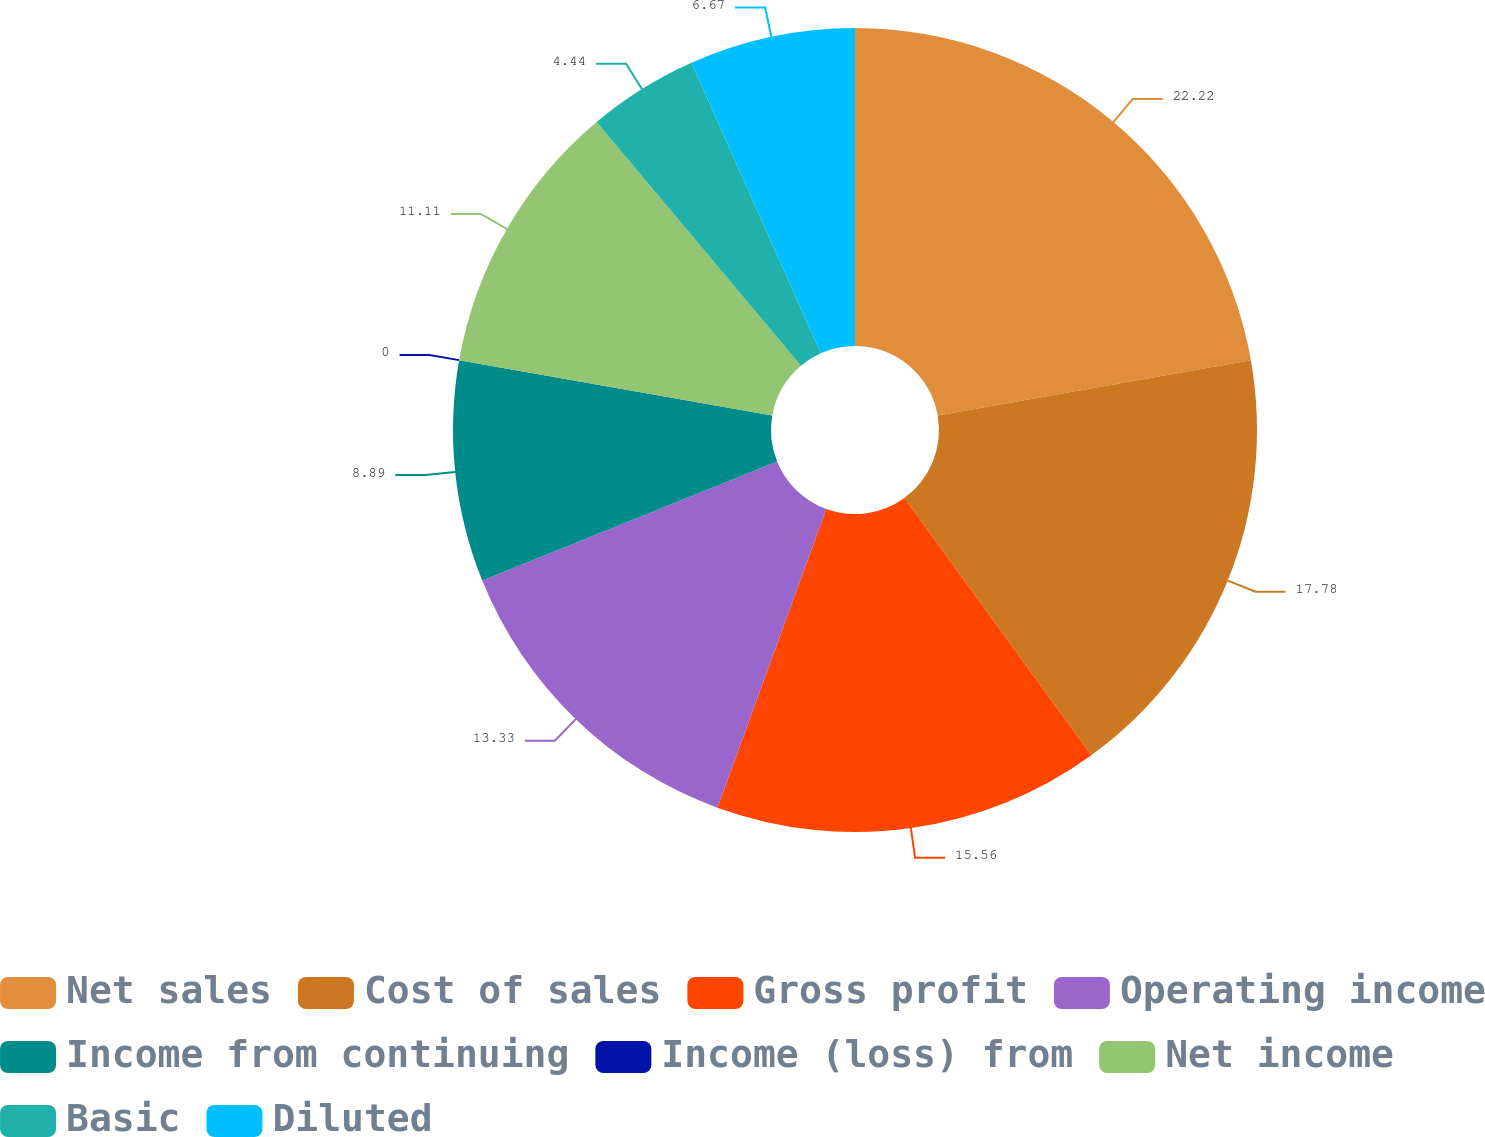<chart> <loc_0><loc_0><loc_500><loc_500><pie_chart><fcel>Net sales<fcel>Cost of sales<fcel>Gross profit<fcel>Operating income<fcel>Income from continuing<fcel>Income (loss) from<fcel>Net income<fcel>Basic<fcel>Diluted<nl><fcel>22.22%<fcel>17.78%<fcel>15.56%<fcel>13.33%<fcel>8.89%<fcel>0.0%<fcel>11.11%<fcel>4.44%<fcel>6.67%<nl></chart> 